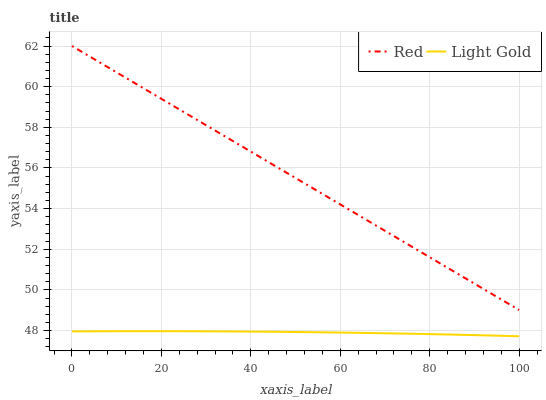Does Red have the minimum area under the curve?
Answer yes or no. No. Is Red the roughest?
Answer yes or no. No. Does Red have the lowest value?
Answer yes or no. No. Is Light Gold less than Red?
Answer yes or no. Yes. Is Red greater than Light Gold?
Answer yes or no. Yes. Does Light Gold intersect Red?
Answer yes or no. No. 